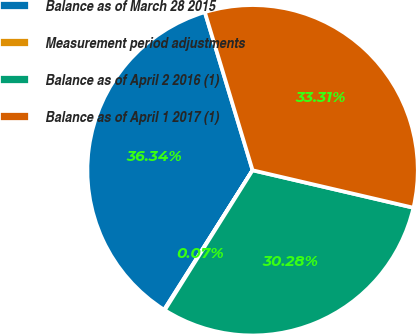Convert chart. <chart><loc_0><loc_0><loc_500><loc_500><pie_chart><fcel>Balance as of March 28 2015<fcel>Measurement period adjustments<fcel>Balance as of April 2 2016 (1)<fcel>Balance as of April 1 2017 (1)<nl><fcel>36.34%<fcel>0.07%<fcel>30.28%<fcel>33.31%<nl></chart> 